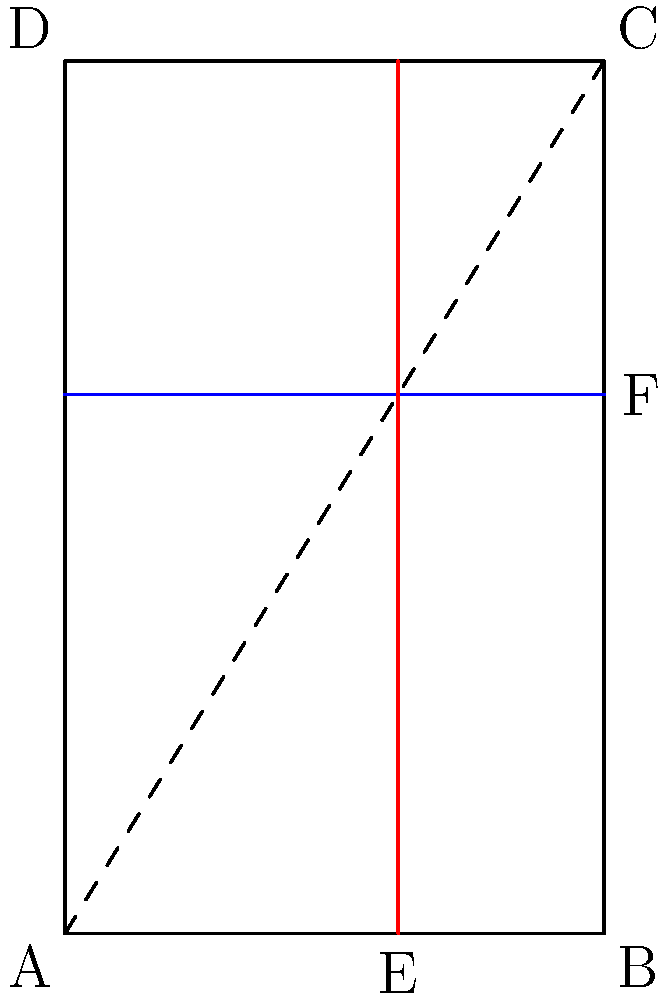In the diagram above, rectangle ABCD represents a classic book page layout. The blue and red lines divide the page according to the golden ratio. If the width of the page is 5 units, what is the approximate height of the page to the nearest hundredth, assuming it follows the golden ratio proportions? To solve this problem, we'll follow these steps:

1) Recall that the golden ratio, often denoted by φ (phi), is approximately equal to 1.618034...

2) In a golden rectangle, the ratio of the longer side to the shorter side is equal to φ.

3) We're given that the width of the page is 5 units. Let's call the height h.

4) According to the golden ratio proportion:

   $$\frac{h}{5} = φ$$

5) We can rearrange this to solve for h:

   $$h = 5φ$$

6) Now, let's calculate:

   $$h = 5 * 1.618034...$$
   $$h ≈ 8.09017...$$

7) Rounding to the nearest hundredth:

   $$h ≈ 8.09$$

Therefore, the height of the page, to the nearest hundredth, is approximately 8.09 units.
Answer: 8.09 units 